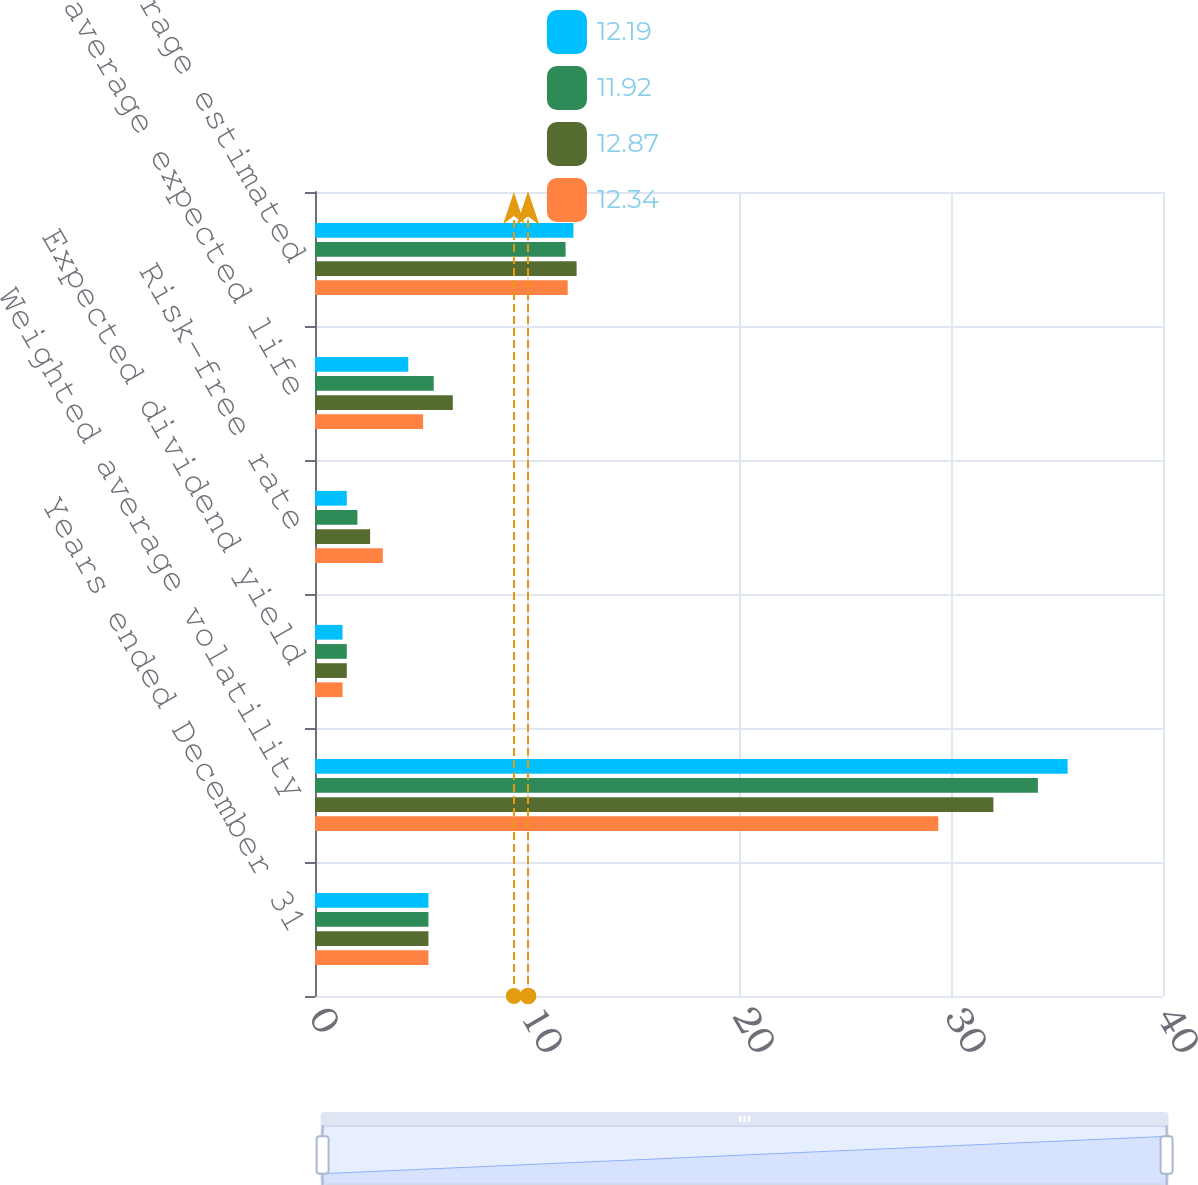Convert chart. <chart><loc_0><loc_0><loc_500><loc_500><stacked_bar_chart><ecel><fcel>Years ended December 31<fcel>Weighted average volatility<fcel>Expected dividend yield<fcel>Risk-free rate<fcel>Weighted average expected life<fcel>Weighted average estimated<nl><fcel>12.19<fcel>5.35<fcel>35.5<fcel>1.3<fcel>1.5<fcel>4.4<fcel>12.19<nl><fcel>11.92<fcel>5.35<fcel>34.1<fcel>1.5<fcel>2<fcel>5.6<fcel>11.82<nl><fcel>12.87<fcel>5.35<fcel>32<fcel>1.5<fcel>2.6<fcel>6.5<fcel>12.34<nl><fcel>12.34<fcel>5.35<fcel>29.4<fcel>1.3<fcel>3.2<fcel>5.1<fcel>11.92<nl></chart> 